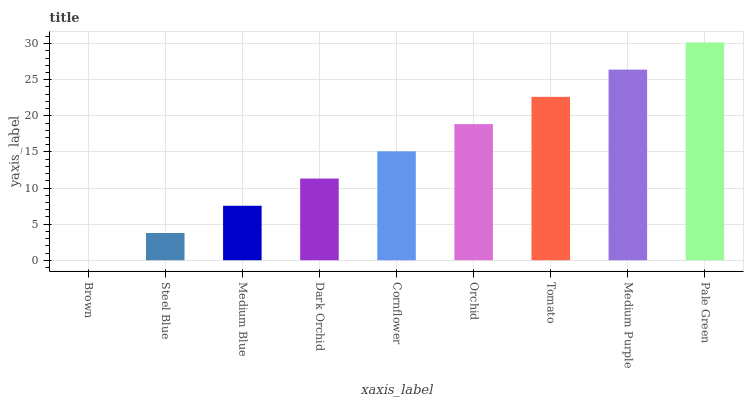Is Brown the minimum?
Answer yes or no. Yes. Is Pale Green the maximum?
Answer yes or no. Yes. Is Steel Blue the minimum?
Answer yes or no. No. Is Steel Blue the maximum?
Answer yes or no. No. Is Steel Blue greater than Brown?
Answer yes or no. Yes. Is Brown less than Steel Blue?
Answer yes or no. Yes. Is Brown greater than Steel Blue?
Answer yes or no. No. Is Steel Blue less than Brown?
Answer yes or no. No. Is Cornflower the high median?
Answer yes or no. Yes. Is Cornflower the low median?
Answer yes or no. Yes. Is Dark Orchid the high median?
Answer yes or no. No. Is Steel Blue the low median?
Answer yes or no. No. 